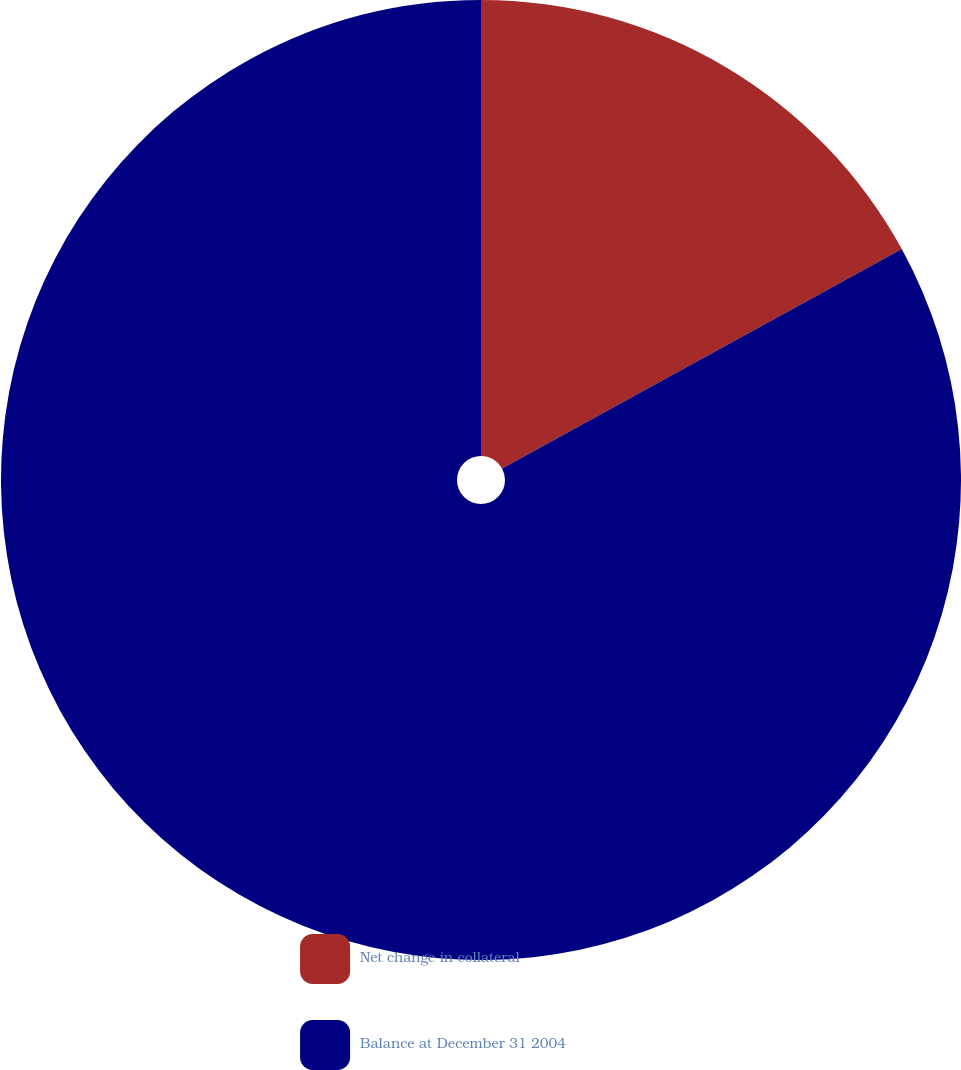Convert chart. <chart><loc_0><loc_0><loc_500><loc_500><pie_chart><fcel>Net change in collateral<fcel>Balance at December 31 2004<nl><fcel>17.01%<fcel>82.99%<nl></chart> 